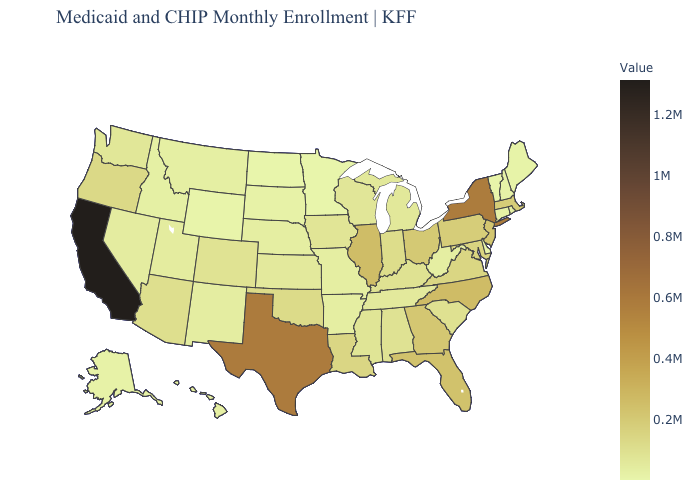Which states have the lowest value in the West?
Give a very brief answer. Wyoming. Among the states that border Colorado , does Wyoming have the lowest value?
Quick response, please. Yes. Which states have the highest value in the USA?
Answer briefly. California. Among the states that border Illinois , does Kentucky have the highest value?
Write a very short answer. No. Does the map have missing data?
Give a very brief answer. No. 